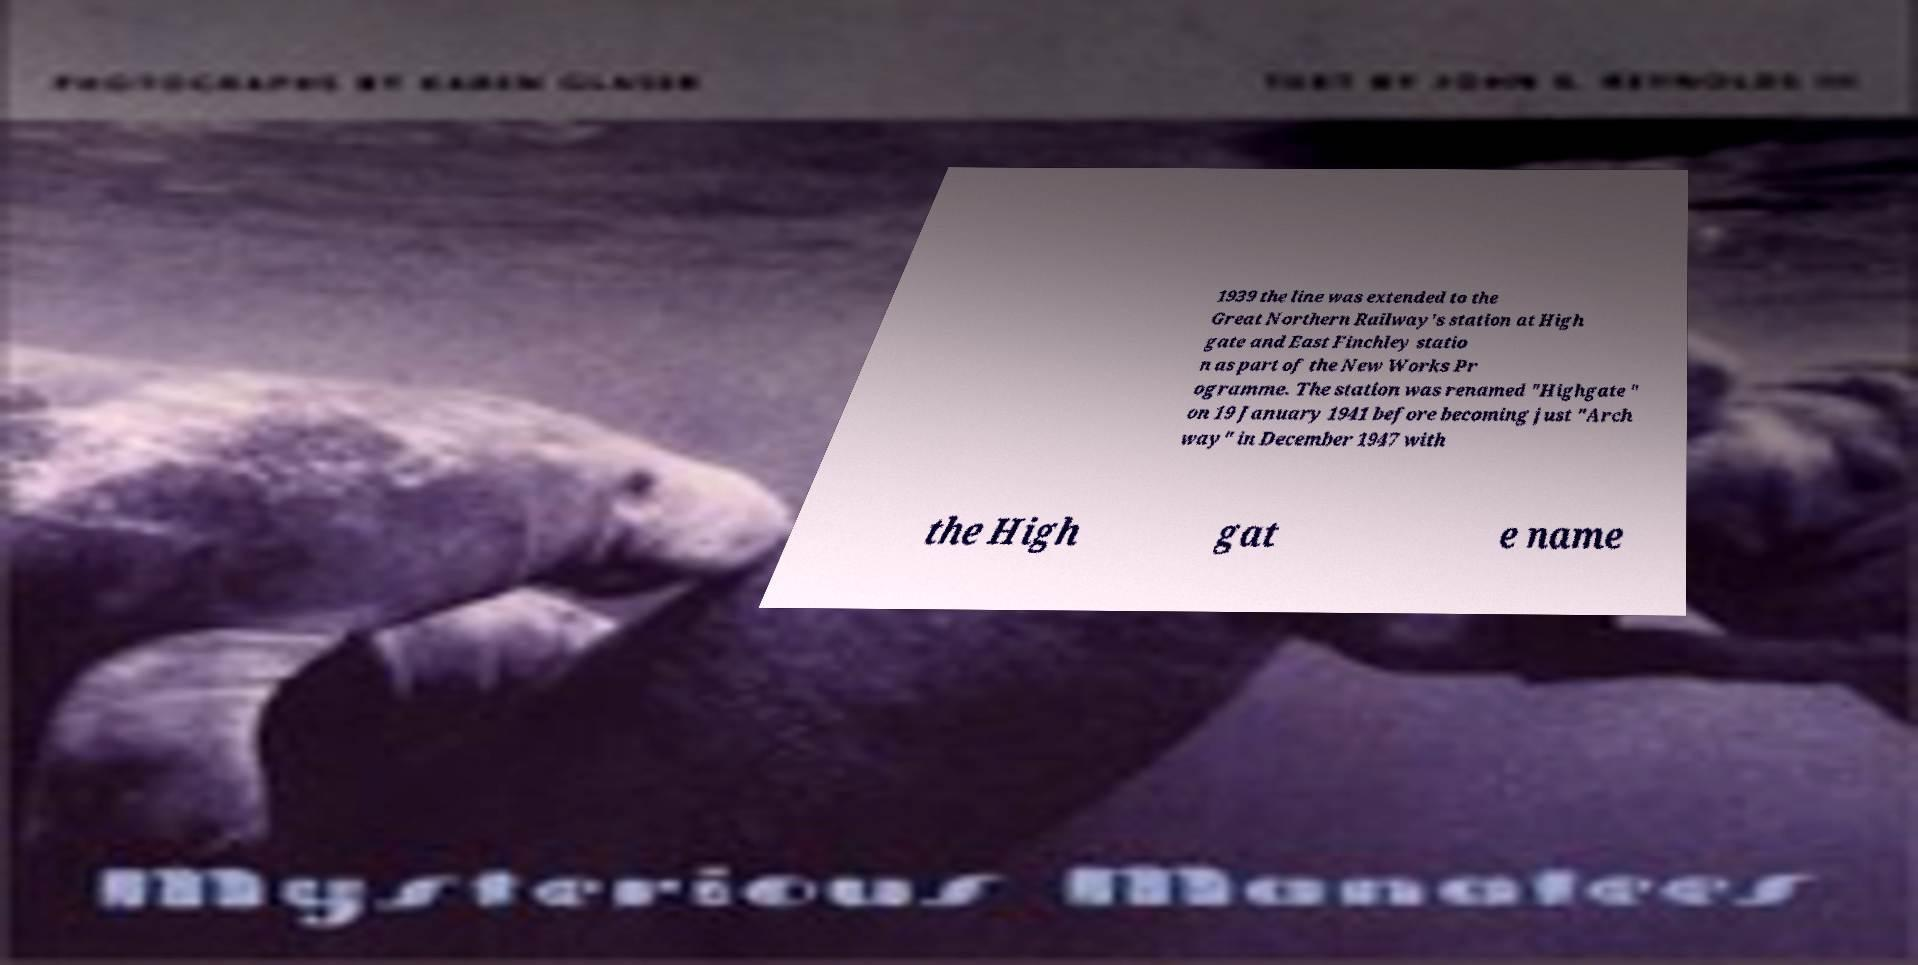Could you assist in decoding the text presented in this image and type it out clearly? 1939 the line was extended to the Great Northern Railway's station at High gate and East Finchley statio n as part of the New Works Pr ogramme. The station was renamed "Highgate " on 19 January 1941 before becoming just "Arch way" in December 1947 with the High gat e name 